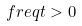<formula> <loc_0><loc_0><loc_500><loc_500>\ f r e q { t } > 0</formula> 